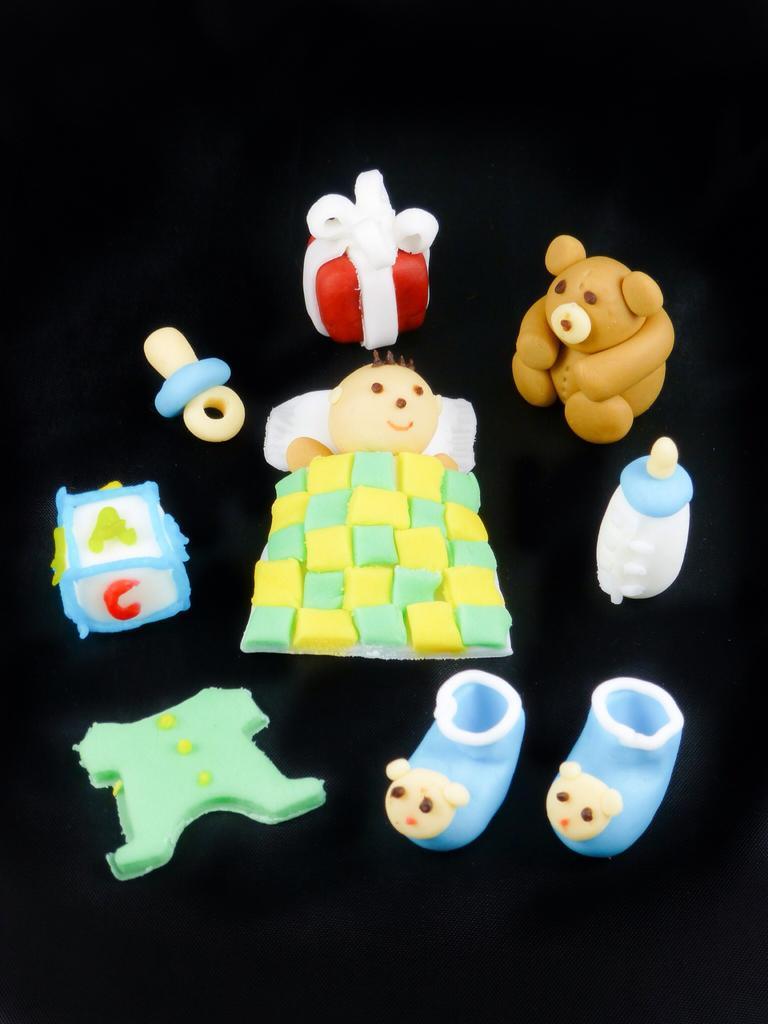Describe this image in one or two sentences. In this picture there is an artificial box, shoes, dress and there is an artificial person lying on the bed and there is a teddy bear and there are objects. At the back there is a black background. 